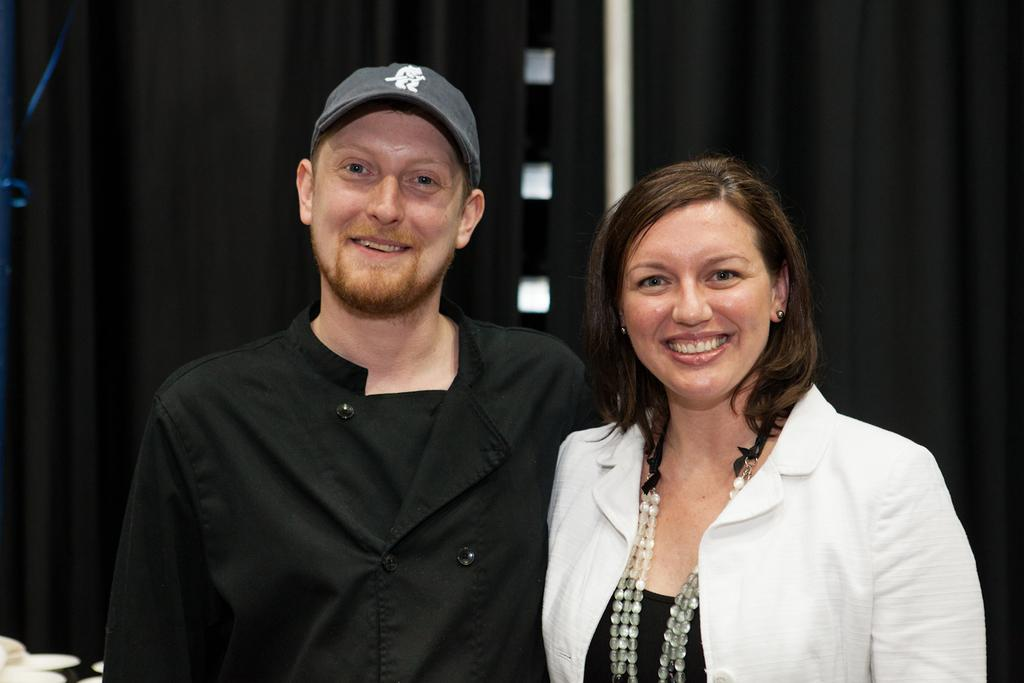How many people are in the image? There are two people in the image, a man and a woman. What are the man and the woman doing in the image? Both the man and the woman are standing and smiling. What can be seen in the background of the image? There are objects in the background of the image. What is present in the image that might be used for window treatment? There are curtains in the image. What type of silk is the man wearing in the image? There is no silk present in the image, nor is the man wearing any silk clothing. How does the tramp contribute to the image? There is no tramp present in the image, so it cannot contribute to the image. 